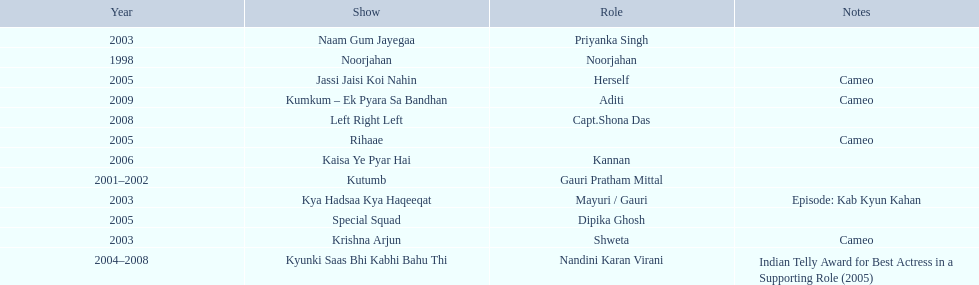How many total television shows has gauri starred in? 12. 